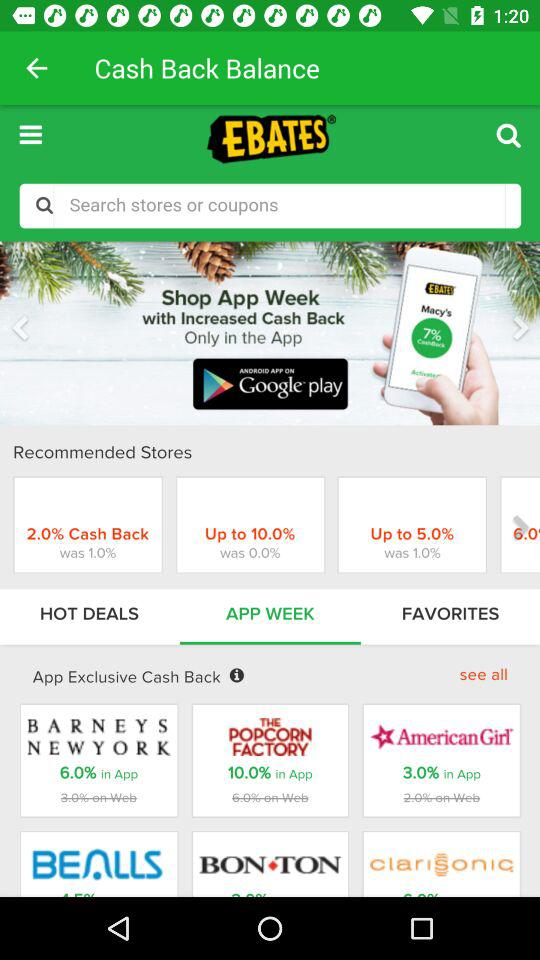What is the application name? The application name is "EBATES". 